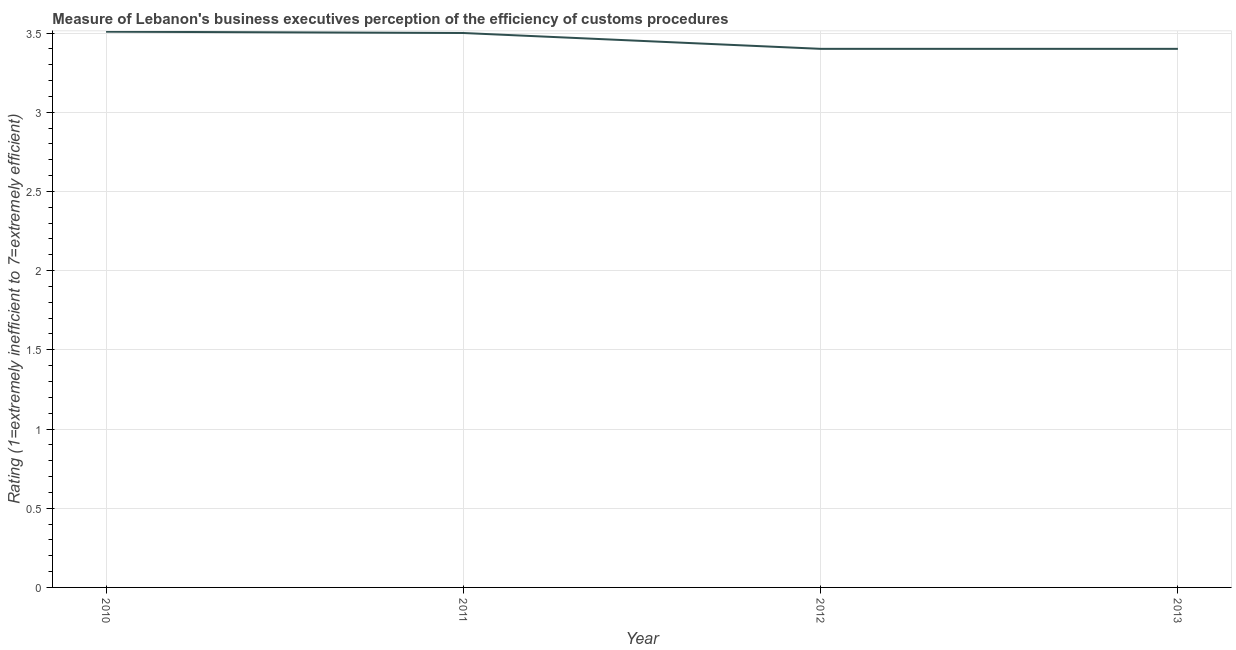Across all years, what is the maximum rating measuring burden of customs procedure?
Ensure brevity in your answer.  3.51. In which year was the rating measuring burden of customs procedure maximum?
Provide a short and direct response. 2010. In which year was the rating measuring burden of customs procedure minimum?
Provide a short and direct response. 2012. What is the sum of the rating measuring burden of customs procedure?
Offer a terse response. 13.81. What is the difference between the rating measuring burden of customs procedure in 2011 and 2013?
Offer a terse response. 0.1. What is the average rating measuring burden of customs procedure per year?
Offer a terse response. 3.45. What is the median rating measuring burden of customs procedure?
Offer a very short reply. 3.45. In how many years, is the rating measuring burden of customs procedure greater than 3.3 ?
Provide a succinct answer. 4. What is the ratio of the rating measuring burden of customs procedure in 2010 to that in 2012?
Your answer should be compact. 1.03. Is the rating measuring burden of customs procedure in 2010 less than that in 2012?
Your answer should be compact. No. What is the difference between the highest and the second highest rating measuring burden of customs procedure?
Your answer should be very brief. 0.01. What is the difference between the highest and the lowest rating measuring burden of customs procedure?
Provide a short and direct response. 0.11. Does the rating measuring burden of customs procedure monotonically increase over the years?
Offer a very short reply. No. What is the difference between two consecutive major ticks on the Y-axis?
Your answer should be very brief. 0.5. Does the graph contain any zero values?
Your response must be concise. No. What is the title of the graph?
Make the answer very short. Measure of Lebanon's business executives perception of the efficiency of customs procedures. What is the label or title of the X-axis?
Provide a short and direct response. Year. What is the label or title of the Y-axis?
Make the answer very short. Rating (1=extremely inefficient to 7=extremely efficient). What is the Rating (1=extremely inefficient to 7=extremely efficient) in 2010?
Your answer should be compact. 3.51. What is the Rating (1=extremely inefficient to 7=extremely efficient) of 2013?
Ensure brevity in your answer.  3.4. What is the difference between the Rating (1=extremely inefficient to 7=extremely efficient) in 2010 and 2011?
Your answer should be very brief. 0.01. What is the difference between the Rating (1=extremely inefficient to 7=extremely efficient) in 2010 and 2012?
Your answer should be compact. 0.11. What is the difference between the Rating (1=extremely inefficient to 7=extremely efficient) in 2010 and 2013?
Your answer should be very brief. 0.11. What is the difference between the Rating (1=extremely inefficient to 7=extremely efficient) in 2011 and 2012?
Make the answer very short. 0.1. What is the difference between the Rating (1=extremely inefficient to 7=extremely efficient) in 2011 and 2013?
Offer a terse response. 0.1. What is the difference between the Rating (1=extremely inefficient to 7=extremely efficient) in 2012 and 2013?
Make the answer very short. 0. What is the ratio of the Rating (1=extremely inefficient to 7=extremely efficient) in 2010 to that in 2012?
Offer a terse response. 1.03. What is the ratio of the Rating (1=extremely inefficient to 7=extremely efficient) in 2010 to that in 2013?
Provide a succinct answer. 1.03. What is the ratio of the Rating (1=extremely inefficient to 7=extremely efficient) in 2011 to that in 2012?
Your answer should be compact. 1.03. 